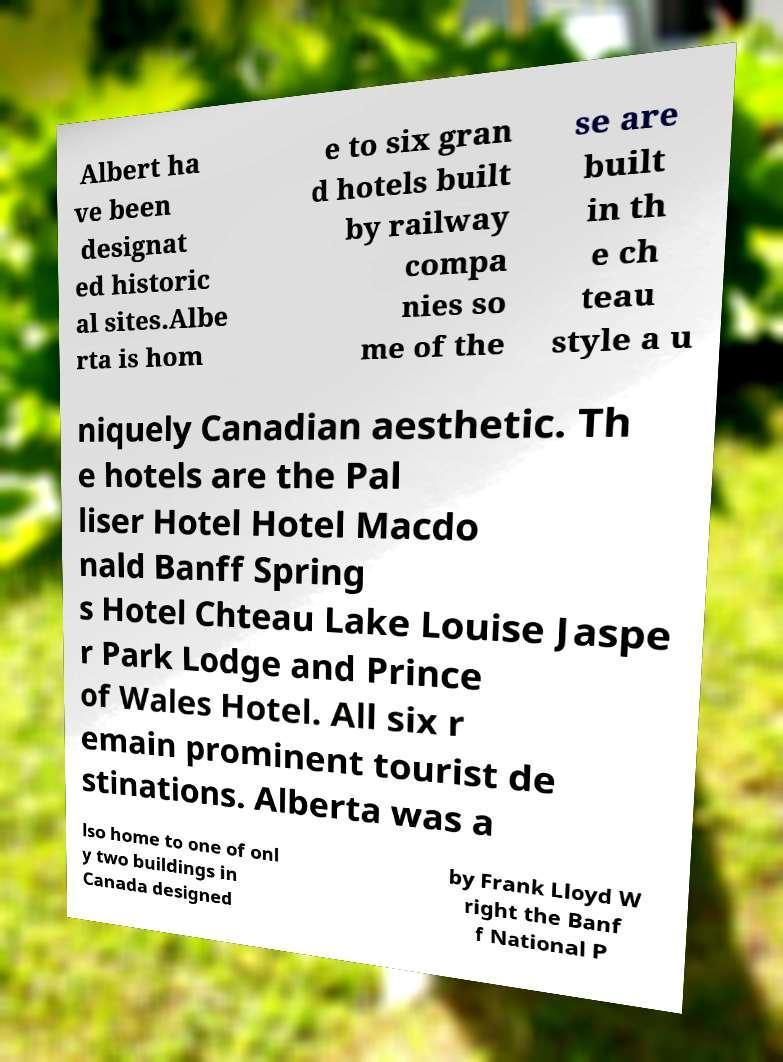Can you accurately transcribe the text from the provided image for me? Albert ha ve been designat ed historic al sites.Albe rta is hom e to six gran d hotels built by railway compa nies so me of the se are built in th e ch teau style a u niquely Canadian aesthetic. Th e hotels are the Pal liser Hotel Hotel Macdo nald Banff Spring s Hotel Chteau Lake Louise Jaspe r Park Lodge and Prince of Wales Hotel. All six r emain prominent tourist de stinations. Alberta was a lso home to one of onl y two buildings in Canada designed by Frank Lloyd W right the Banf f National P 